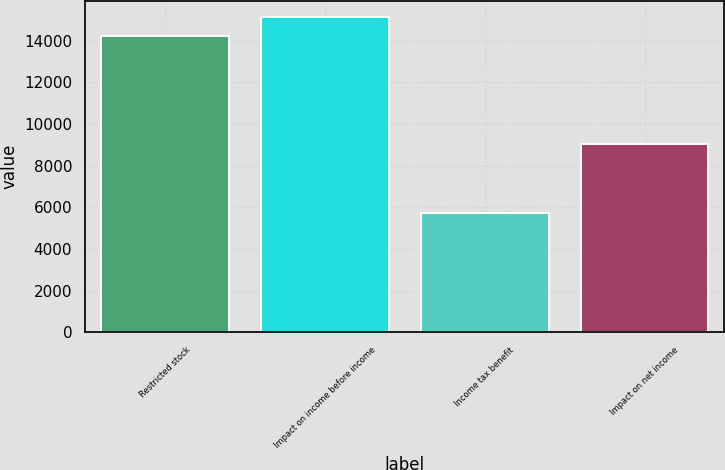Convert chart. <chart><loc_0><loc_0><loc_500><loc_500><bar_chart><fcel>Restricted stock<fcel>Impact on income before income<fcel>Income tax benefit<fcel>Impact on net income<nl><fcel>14238<fcel>15141.3<fcel>5728<fcel>9033<nl></chart> 